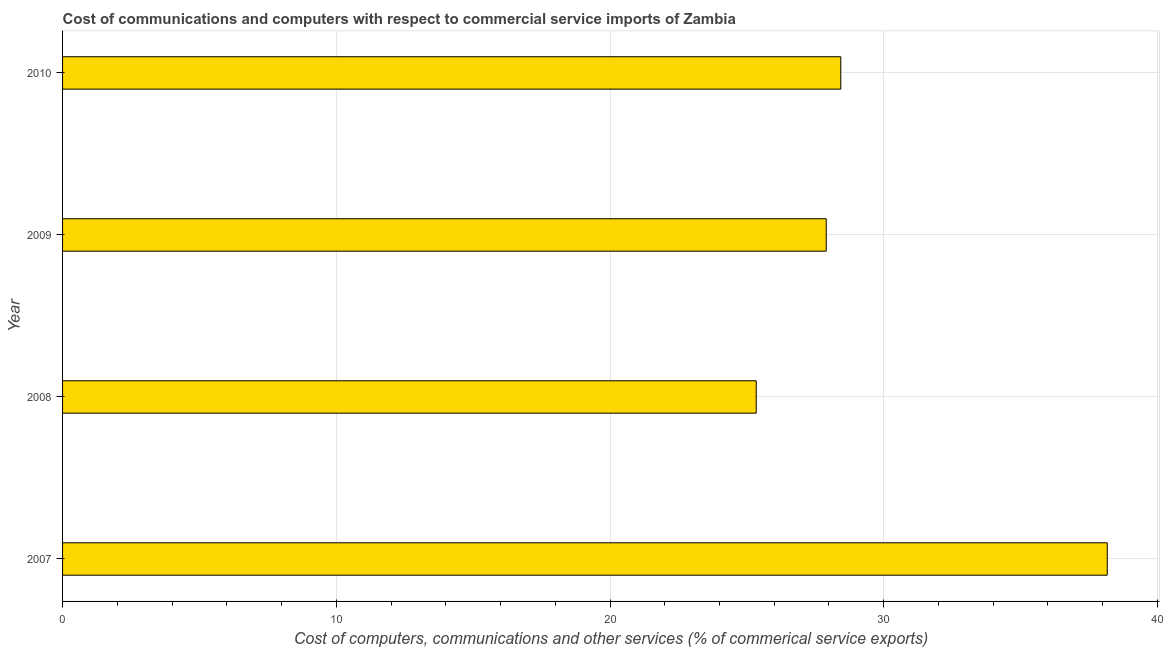Does the graph contain grids?
Provide a short and direct response. Yes. What is the title of the graph?
Make the answer very short. Cost of communications and computers with respect to commercial service imports of Zambia. What is the label or title of the X-axis?
Keep it short and to the point. Cost of computers, communications and other services (% of commerical service exports). What is the cost of communications in 2010?
Provide a short and direct response. 28.43. Across all years, what is the maximum cost of communications?
Give a very brief answer. 38.17. Across all years, what is the minimum  computer and other services?
Give a very brief answer. 25.34. What is the sum of the cost of communications?
Offer a very short reply. 119.84. What is the difference between the  computer and other services in 2007 and 2009?
Provide a succinct answer. 10.27. What is the average  computer and other services per year?
Provide a short and direct response. 29.96. What is the median  computer and other services?
Provide a short and direct response. 28.17. In how many years, is the  computer and other services greater than 38 %?
Ensure brevity in your answer.  1. Do a majority of the years between 2008 and 2007 (inclusive) have  computer and other services greater than 24 %?
Ensure brevity in your answer.  No. What is the ratio of the  computer and other services in 2008 to that in 2010?
Provide a short and direct response. 0.89. What is the difference between the highest and the second highest cost of communications?
Your response must be concise. 9.74. Is the sum of the  computer and other services in 2008 and 2009 greater than the maximum  computer and other services across all years?
Offer a terse response. Yes. What is the difference between the highest and the lowest  computer and other services?
Keep it short and to the point. 12.82. How many bars are there?
Offer a terse response. 4. What is the difference between two consecutive major ticks on the X-axis?
Your response must be concise. 10. Are the values on the major ticks of X-axis written in scientific E-notation?
Give a very brief answer. No. What is the Cost of computers, communications and other services (% of commerical service exports) of 2007?
Provide a succinct answer. 38.17. What is the Cost of computers, communications and other services (% of commerical service exports) in 2008?
Provide a short and direct response. 25.34. What is the Cost of computers, communications and other services (% of commerical service exports) of 2009?
Ensure brevity in your answer.  27.9. What is the Cost of computers, communications and other services (% of commerical service exports) in 2010?
Your answer should be compact. 28.43. What is the difference between the Cost of computers, communications and other services (% of commerical service exports) in 2007 and 2008?
Your response must be concise. 12.82. What is the difference between the Cost of computers, communications and other services (% of commerical service exports) in 2007 and 2009?
Make the answer very short. 10.27. What is the difference between the Cost of computers, communications and other services (% of commerical service exports) in 2007 and 2010?
Offer a very short reply. 9.74. What is the difference between the Cost of computers, communications and other services (% of commerical service exports) in 2008 and 2009?
Keep it short and to the point. -2.56. What is the difference between the Cost of computers, communications and other services (% of commerical service exports) in 2008 and 2010?
Your answer should be compact. -3.09. What is the difference between the Cost of computers, communications and other services (% of commerical service exports) in 2009 and 2010?
Provide a short and direct response. -0.53. What is the ratio of the Cost of computers, communications and other services (% of commerical service exports) in 2007 to that in 2008?
Provide a succinct answer. 1.51. What is the ratio of the Cost of computers, communications and other services (% of commerical service exports) in 2007 to that in 2009?
Provide a short and direct response. 1.37. What is the ratio of the Cost of computers, communications and other services (% of commerical service exports) in 2007 to that in 2010?
Your answer should be compact. 1.34. What is the ratio of the Cost of computers, communications and other services (% of commerical service exports) in 2008 to that in 2009?
Make the answer very short. 0.91. What is the ratio of the Cost of computers, communications and other services (% of commerical service exports) in 2008 to that in 2010?
Ensure brevity in your answer.  0.89. 